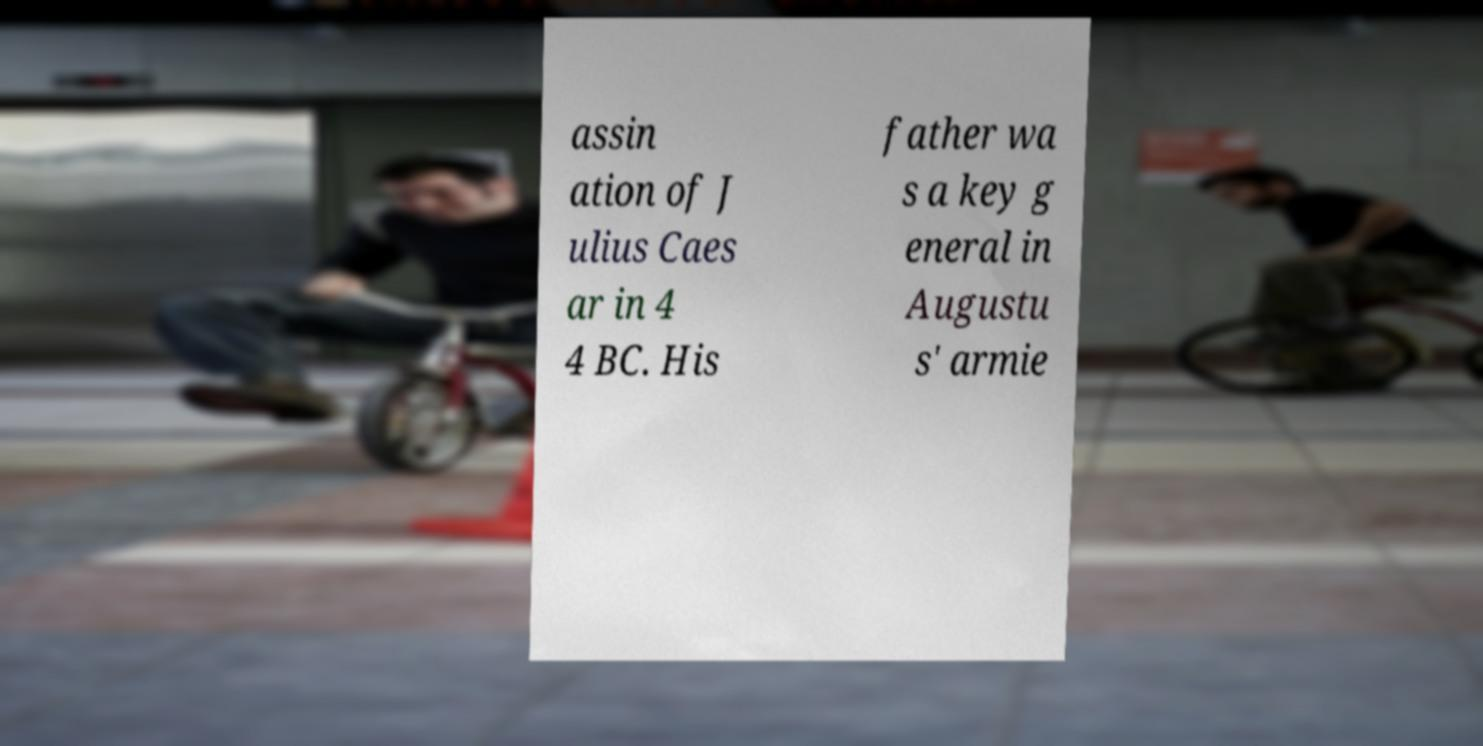For documentation purposes, I need the text within this image transcribed. Could you provide that? assin ation of J ulius Caes ar in 4 4 BC. His father wa s a key g eneral in Augustu s' armie 